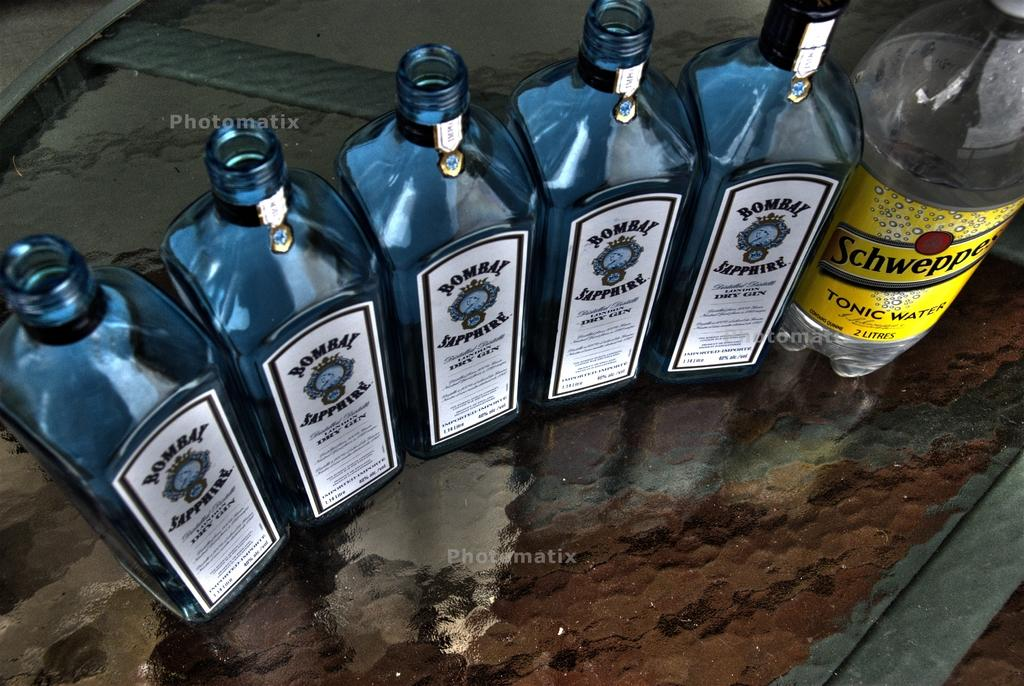<image>
Share a concise interpretation of the image provided. Several bottles of Bombay Sapphire are lined up next to a bottle of Schweppes tonic water. 